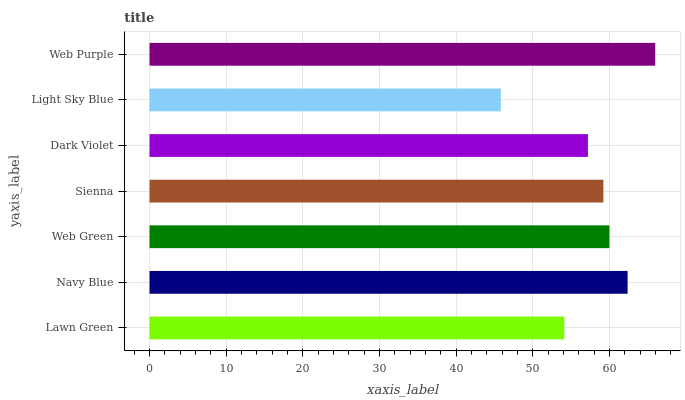Is Light Sky Blue the minimum?
Answer yes or no. Yes. Is Web Purple the maximum?
Answer yes or no. Yes. Is Navy Blue the minimum?
Answer yes or no. No. Is Navy Blue the maximum?
Answer yes or no. No. Is Navy Blue greater than Lawn Green?
Answer yes or no. Yes. Is Lawn Green less than Navy Blue?
Answer yes or no. Yes. Is Lawn Green greater than Navy Blue?
Answer yes or no. No. Is Navy Blue less than Lawn Green?
Answer yes or no. No. Is Sienna the high median?
Answer yes or no. Yes. Is Sienna the low median?
Answer yes or no. Yes. Is Navy Blue the high median?
Answer yes or no. No. Is Navy Blue the low median?
Answer yes or no. No. 